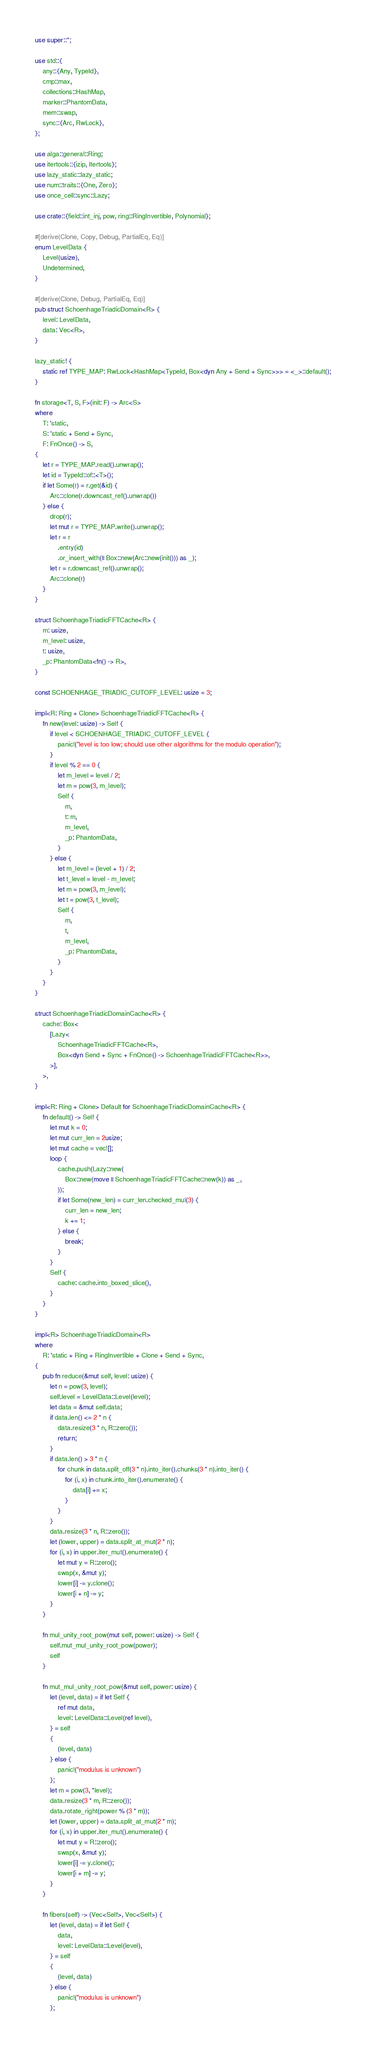Convert code to text. <code><loc_0><loc_0><loc_500><loc_500><_Rust_>use super::*;

use std::{
    any::{Any, TypeId},
    cmp::max,
    collections::HashMap,
    marker::PhantomData,
    mem::swap,
    sync::{Arc, RwLock},
};

use alga::general::Ring;
use itertools::{izip, Itertools};
use lazy_static::lazy_static;
use num::traits::{One, Zero};
use once_cell::sync::Lazy;

use crate::{field::int_inj, pow, ring::RingInvertible, Polynomial};

#[derive(Clone, Copy, Debug, PartialEq, Eq)]
enum LevelData {
    Level(usize),
    Undetermined,
}

#[derive(Clone, Debug, PartialEq, Eq)]
pub struct SchoenhageTriadicDomain<R> {
    level: LevelData,
    data: Vec<R>,
}

lazy_static! {
    static ref TYPE_MAP: RwLock<HashMap<TypeId, Box<dyn Any + Send + Sync>>> = <_>::default();
}

fn storage<T, S, F>(init: F) -> Arc<S>
where
    T: 'static,
    S: 'static + Send + Sync,
    F: FnOnce() -> S,
{
    let r = TYPE_MAP.read().unwrap();
    let id = TypeId::of::<T>();
    if let Some(r) = r.get(&id) {
        Arc::clone(r.downcast_ref().unwrap())
    } else {
        drop(r);
        let mut r = TYPE_MAP.write().unwrap();
        let r = r
            .entry(id)
            .or_insert_with(|| Box::new(Arc::new(init())) as _);
        let r = r.downcast_ref().unwrap();
        Arc::clone(r)
    }
}

struct SchoenhageTriadicFFTCache<R> {
    m: usize,
    m_level: usize,
    t: usize,
    _p: PhantomData<fn() -> R>,
}

const SCHOENHAGE_TRIADIC_CUTOFF_LEVEL: usize = 3;

impl<R: Ring + Clone> SchoenhageTriadicFFTCache<R> {
    fn new(level: usize) -> Self {
        if level < SCHOENHAGE_TRIADIC_CUTOFF_LEVEL {
            panic!("level is too low; should use other algorithms for the modulo operation");
        }
        if level % 2 == 0 {
            let m_level = level / 2;
            let m = pow(3, m_level);
            Self {
                m,
                t: m,
                m_level,
                _p: PhantomData,
            }
        } else {
            let m_level = (level + 1) / 2;
            let t_level = level - m_level;
            let m = pow(3, m_level);
            let t = pow(3, t_level);
            Self {
                m,
                t,
                m_level,
                _p: PhantomData,
            }
        }
    }
}

struct SchoenhageTriadicDomainCache<R> {
    cache: Box<
        [Lazy<
            SchoenhageTriadicFFTCache<R>,
            Box<dyn Send + Sync + FnOnce() -> SchoenhageTriadicFFTCache<R>>,
        >],
    >,
}

impl<R: Ring + Clone> Default for SchoenhageTriadicDomainCache<R> {
    fn default() -> Self {
        let mut k = 0;
        let mut curr_len = 2usize;
        let mut cache = vec![];
        loop {
            cache.push(Lazy::new(
                Box::new(move || SchoenhageTriadicFFTCache::new(k)) as _,
            ));
            if let Some(new_len) = curr_len.checked_mul(3) {
                curr_len = new_len;
                k += 1;
            } else {
                break;
            }
        }
        Self {
            cache: cache.into_boxed_slice(),
        }
    }
}

impl<R> SchoenhageTriadicDomain<R>
where
    R: 'static + Ring + RingInvertible + Clone + Send + Sync,
{
    pub fn reduce(&mut self, level: usize) {
        let n = pow(3, level);
        self.level = LevelData::Level(level);
        let data = &mut self.data;
        if data.len() <= 2 * n {
            data.resize(3 * n, R::zero());
            return;
        }
        if data.len() > 3 * n {
            for chunk in data.split_off(3 * n).into_iter().chunks(3 * n).into_iter() {
                for (i, x) in chunk.into_iter().enumerate() {
                    data[i] += x;
                }
            }
        }
        data.resize(3 * n, R::zero());
        let (lower, upper) = data.split_at_mut(2 * n);
        for (i, x) in upper.iter_mut().enumerate() {
            let mut y = R::zero();
            swap(x, &mut y);
            lower[i] -= y.clone();
            lower[i + n] -= y;
        }
    }

    fn mul_unity_root_pow(mut self, power: usize) -> Self {
        self.mut_mul_unity_root_pow(power);
        self
    }

    fn mut_mul_unity_root_pow(&mut self, power: usize) {
        let (level, data) = if let Self {
            ref mut data,
            level: LevelData::Level(ref level),
        } = self
        {
            (level, data)
        } else {
            panic!("modulus is unknown")
        };
        let m = pow(3, *level);
        data.resize(3 * m, R::zero());
        data.rotate_right(power % (3 * m));
        let (lower, upper) = data.split_at_mut(2 * m);
        for (i, x) in upper.iter_mut().enumerate() {
            let mut y = R::zero();
            swap(x, &mut y);
            lower[i] -= y.clone();
            lower[i + m] -= y;
        }
    }

    fn fibers(self) -> (Vec<Self>, Vec<Self>) {
        let (level, data) = if let Self {
            data,
            level: LevelData::Level(level),
        } = self
        {
            (level, data)
        } else {
            panic!("modulus is unknown")
        };</code> 